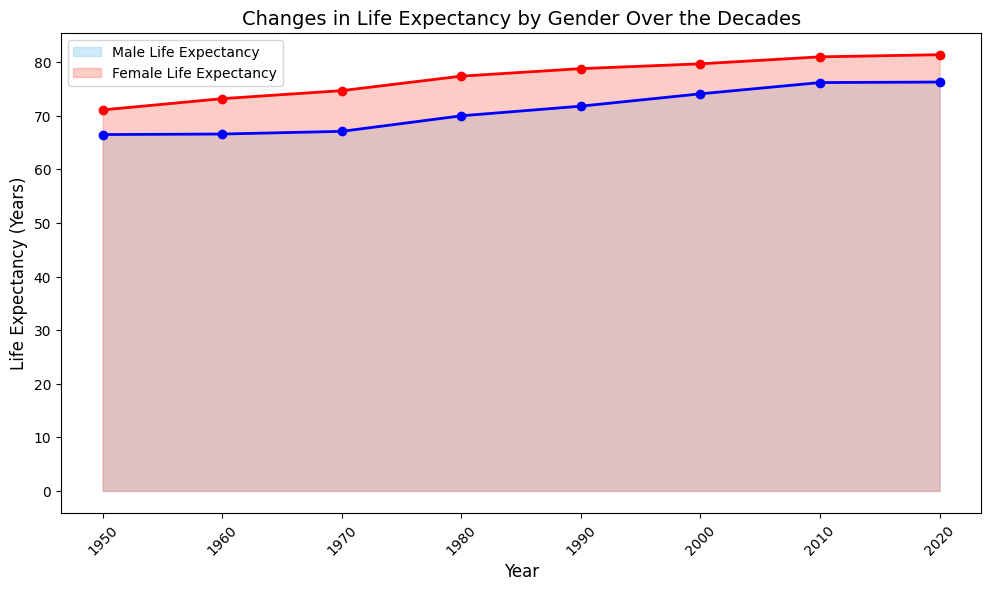What is the overall trend in male life expectancy from 1950 to 2020? Male life expectancy shows a general upward trend from 66.5 years in 1950 to 76.3 years in 2020.
Answer: Upward Which year shows the largest increase in female life expectancy compared to the previous decade? To find the largest increase, note the differences between consecutive decades: 1960-1950: 73.2-71.1=2.1, 1970-1960: 74.7-73.2=1.5, 1980-1970: 77.4-74.7=2.7, 1990-1980: 78.8-77.4=1.4, 2000-1990: 79.7-78.8=0.9, 2010-2000: 81.0-79.7=1.3, 2020-2010: 81.4-81.0=0.4. The largest increase happens between 1970 and 1980.
Answer: 1980 How much higher was female life expectancy than male life expectancy in 2020? Female life expectancy in 2020 was 81.4 years and male life expectancy was 76.3 years. The difference is 81.4 - 76.3 = 5.1 years.
Answer: 5.1 years Between which consecutive decades did male life expectancy experience the highest increase? Calculate differences: 1960-1950: 66.6-66.5=0.1, 1970-1960: 67.1-66.6=0.5, 1980-1970: 70.0-67.1=2.9, 1990-1980: 71.8-70.0=1.8, 2000-1990: 74.1-71.8=2.3, 2010-2000: 76.2-74.1=2.1, 2020-2010: 76.3-76.2=0.1. The largest increase is from 1970 to 1980 with 2.9 years.
Answer: 1970 to 1980 How do the overall trends in life expectancy for males and females compare from 1950 to 2020? Both male and female life expectancy show an upward trend over the period. Female life expectancy is consistently higher than male life expectancy in every recorded decade.
Answer: Both upward, Female higher Which gender had a higher rate of increase in life expectancy between 1950 and 2020? Calculate the total increase: Male: 76.3-66.5=9.8 years, Female: 81.4-71.1=10.3 years. Female life expectancy increased by 10.3 years, which is higher than the 9.8 years increase in male life expectancy.
Answer: Female During which decade did both male and female life expectancy cross the 70-year mark? Male life expectancy first crosses 70 years in the 1980s, reaching 70.0, and females surpassed 70 years in the 1960s with 73.2 years.
Answer: 1980s What is the average life expectancy for males from 1950 to 2020? Sum of male life expectancy values: 66.5 + 66.6 + 67.1 + 70.0 + 71.8 + 74.1 + 76.2 + 76.3 = 568.6. Number of decades = 8. The average is 568.6 / 8 = 71.075 years.
Answer: 71.075 years Is there any decade in which both genders experienced the same trend (either both increasing/stagnant or both decreasing)? Examine the changes for both genders across each decade. For each period, both male and female life expectancy either increased or were stagnant. There is no decade with opposite trends in life expectancy for the genders.
Answer: Both increasing/stagnant every decade 